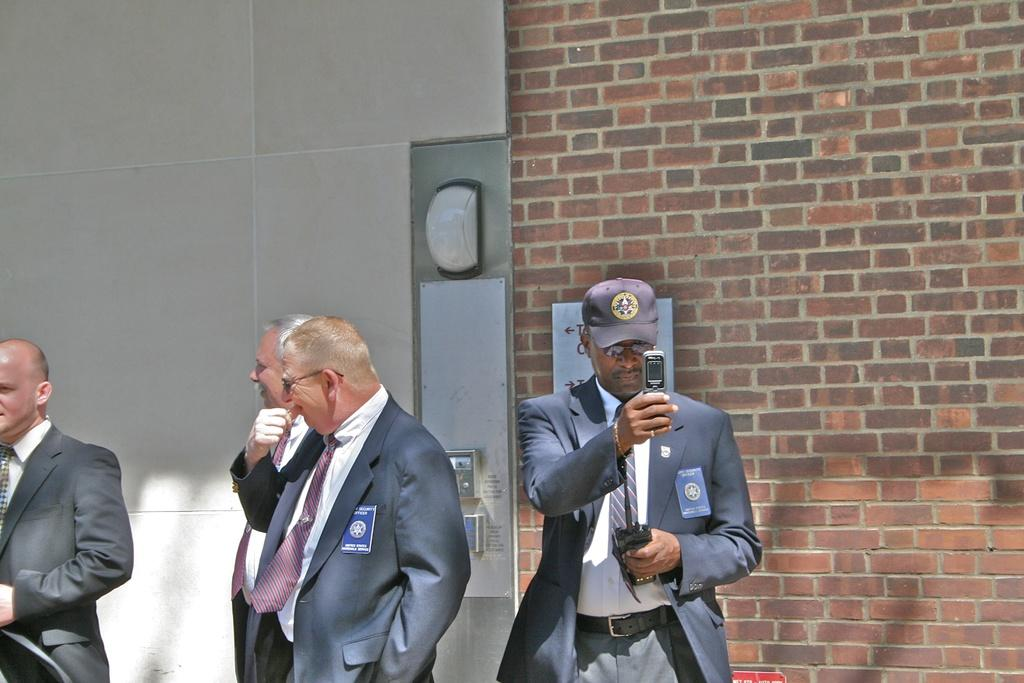How many people are in the image? There are four people standing in the image. What is one of the people doing? One man is catching a mobile phone. What is behind the people in the image? There is a wall behind the people. Can you describe anything on the wall? There is a light present on the wall. What type of organization is the man holding in the image? There is no organization visible in the image; the man is catching a mobile phone. Can you tell me what the woman's locket contains in the image? There is no locket present in the image. 